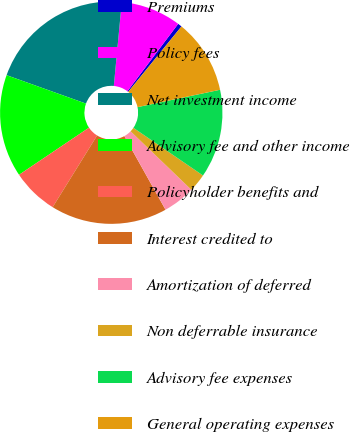<chart> <loc_0><loc_0><loc_500><loc_500><pie_chart><fcel>Premiums<fcel>Policy fees<fcel>Net investment income<fcel>Advisory fee and other income<fcel>Policyholder benefits and<fcel>Interest credited to<fcel>Amortization of deferred<fcel>Non deferrable insurance<fcel>Advisory fee expenses<fcel>General operating expenses<nl><fcel>0.6%<fcel>8.77%<fcel>21.04%<fcel>14.91%<fcel>6.73%<fcel>16.95%<fcel>4.69%<fcel>2.64%<fcel>12.86%<fcel>10.82%<nl></chart> 